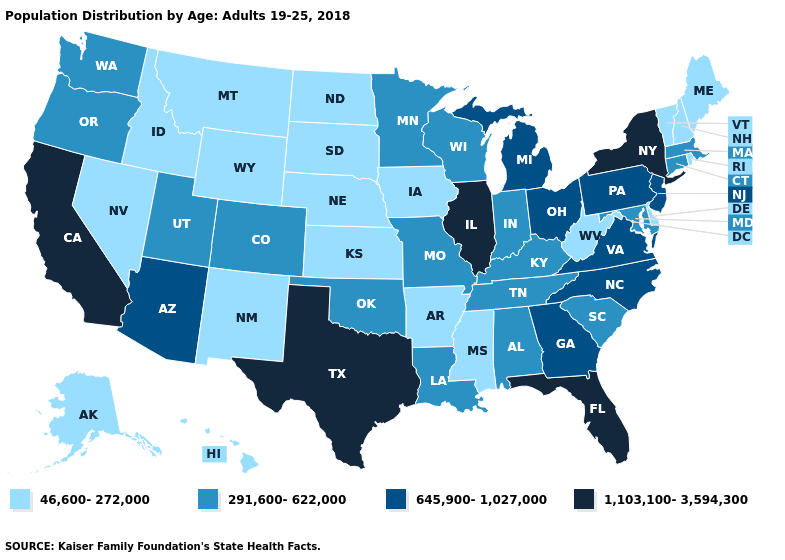Name the states that have a value in the range 291,600-622,000?
Be succinct. Alabama, Colorado, Connecticut, Indiana, Kentucky, Louisiana, Maryland, Massachusetts, Minnesota, Missouri, Oklahoma, Oregon, South Carolina, Tennessee, Utah, Washington, Wisconsin. Among the states that border Kentucky , does Missouri have the lowest value?
Short answer required. No. Name the states that have a value in the range 46,600-272,000?
Give a very brief answer. Alaska, Arkansas, Delaware, Hawaii, Idaho, Iowa, Kansas, Maine, Mississippi, Montana, Nebraska, Nevada, New Hampshire, New Mexico, North Dakota, Rhode Island, South Dakota, Vermont, West Virginia, Wyoming. Does Massachusetts have a higher value than North Dakota?
Keep it brief. Yes. What is the value of Colorado?
Short answer required. 291,600-622,000. Does Iowa have a higher value than Hawaii?
Answer briefly. No. What is the value of Nebraska?
Answer briefly. 46,600-272,000. Which states have the lowest value in the Northeast?
Quick response, please. Maine, New Hampshire, Rhode Island, Vermont. What is the highest value in the USA?
Be succinct. 1,103,100-3,594,300. Name the states that have a value in the range 46,600-272,000?
Keep it brief. Alaska, Arkansas, Delaware, Hawaii, Idaho, Iowa, Kansas, Maine, Mississippi, Montana, Nebraska, Nevada, New Hampshire, New Mexico, North Dakota, Rhode Island, South Dakota, Vermont, West Virginia, Wyoming. Does Minnesota have the lowest value in the USA?
Answer briefly. No. What is the lowest value in states that border Texas?
Quick response, please. 46,600-272,000. Does the map have missing data?
Short answer required. No. Which states have the lowest value in the USA?
Be succinct. Alaska, Arkansas, Delaware, Hawaii, Idaho, Iowa, Kansas, Maine, Mississippi, Montana, Nebraska, Nevada, New Hampshire, New Mexico, North Dakota, Rhode Island, South Dakota, Vermont, West Virginia, Wyoming. 